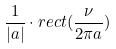<formula> <loc_0><loc_0><loc_500><loc_500>\frac { 1 } { | a | } \cdot r e c t ( \frac { \nu } { 2 \pi a } )</formula> 